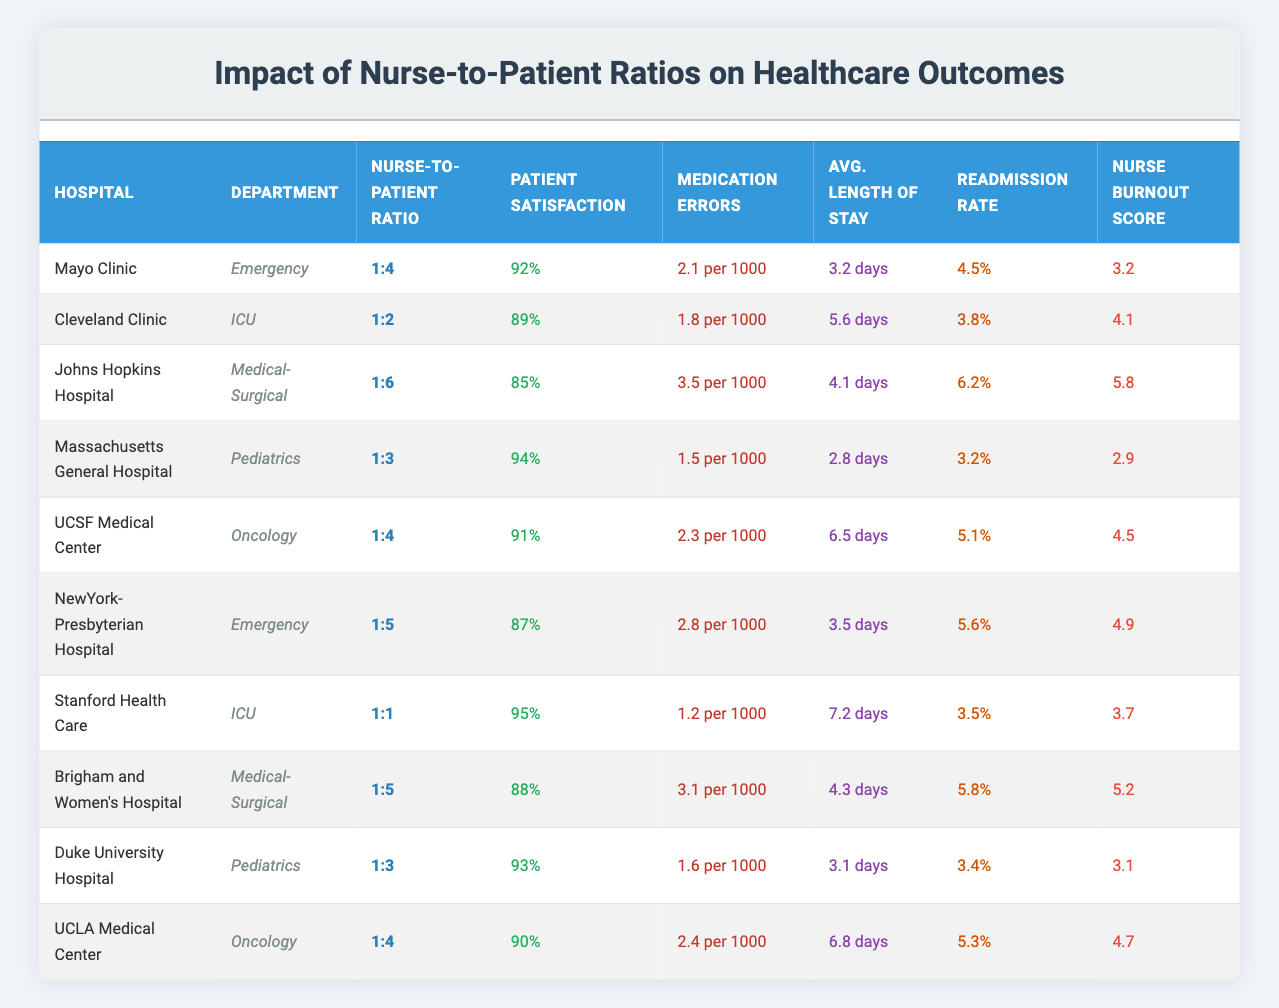What is the Nurse-to-Patient Ratio for Stanford Health Care in the ICU? Stanford Health Care has a Nurse-to-Patient Ratio of 1:1 in the ICU as specified in the table.
Answer: 1:1 Which hospital has the highest Patient Satisfaction Score? Massachusetts General Hospital has the highest Patient Satisfaction Score of 94%, looking at the Patient Satisfaction column across all rows.
Answer: 94% What is the Readmission Rate Percentage for Johns Hopkins Hospital in the Medical-Surgical department? The Readmission Rate Percentage for Johns Hopkins Hospital in the Medical-Surgical department is 6.2% as indicated in the table.
Answer: 6.2% How many hospitals have a Nurse-to-Patient Ratio of 1:4? There are 3 hospitals (Mayo Clinic, UCSF Medical Center, and UCLA Medical Center) with a Nurse-to-Patient Ratio of 1:4 from the data gathered.
Answer: 3 What is the average Medication Errors per 1000 Patients across all hospitals? Adding the Medication Errors per 1000 Patients for each hospital gives a total of 2.1 + 1.8 + 3.5 + 1.5 + 2.3 + 2.8 + 1.2 + 3.1 + 1.6 + 2.4 = 22.2. Dividing this by the number of hospitals, which is 10, results in an average of 2.22.
Answer: 2.22 Does a lower Nurse-to-Patient Ratio correlate with higher Patient Satisfaction Scores based on the table? Analyzing the data shows that hospitals with lower Nurse-to-Patient Ratios (such as Stanford Health Care at 1:1 with 95% satisfaction) generally have higher Patient Satisfaction Scores, while those with higher Ratios have lower scores; thus, a correlation does exist.
Answer: Yes What is the difference in Nurse Burnout Score between the highest and lowest rated hospitals? The highest Nurse Burnout Score is 5.8 from Johns Hopkins Hospital, and the lowest is 2.9 from Massachusetts General Hospital; the difference is 5.8 - 2.9 = 2.9.
Answer: 2.9 Which department at Cleveland Clinic has the lowest Medication Errors per 1000 Patients? Cleveland Clinic's ICU, with 1.8 per 1000 Patients, reports the lowest Medication Errors out of the departments presented in the table.
Answer: 1.8 Is the Average Length of Stay in Emergency departments consistently lower than in ICU departments based on this data? Comparing the Average Length of Stay, Emergency departments (for Mayo Clinic 3.2 and NewYork-Presbyterian Hospital 3.5) show lower averages than the ICU departments (Cleveland Clinic 5.6 and Stanford Health Care 7.2), indicating consistency in the pattern that Emergency department stays are generally shorter.
Answer: Yes 